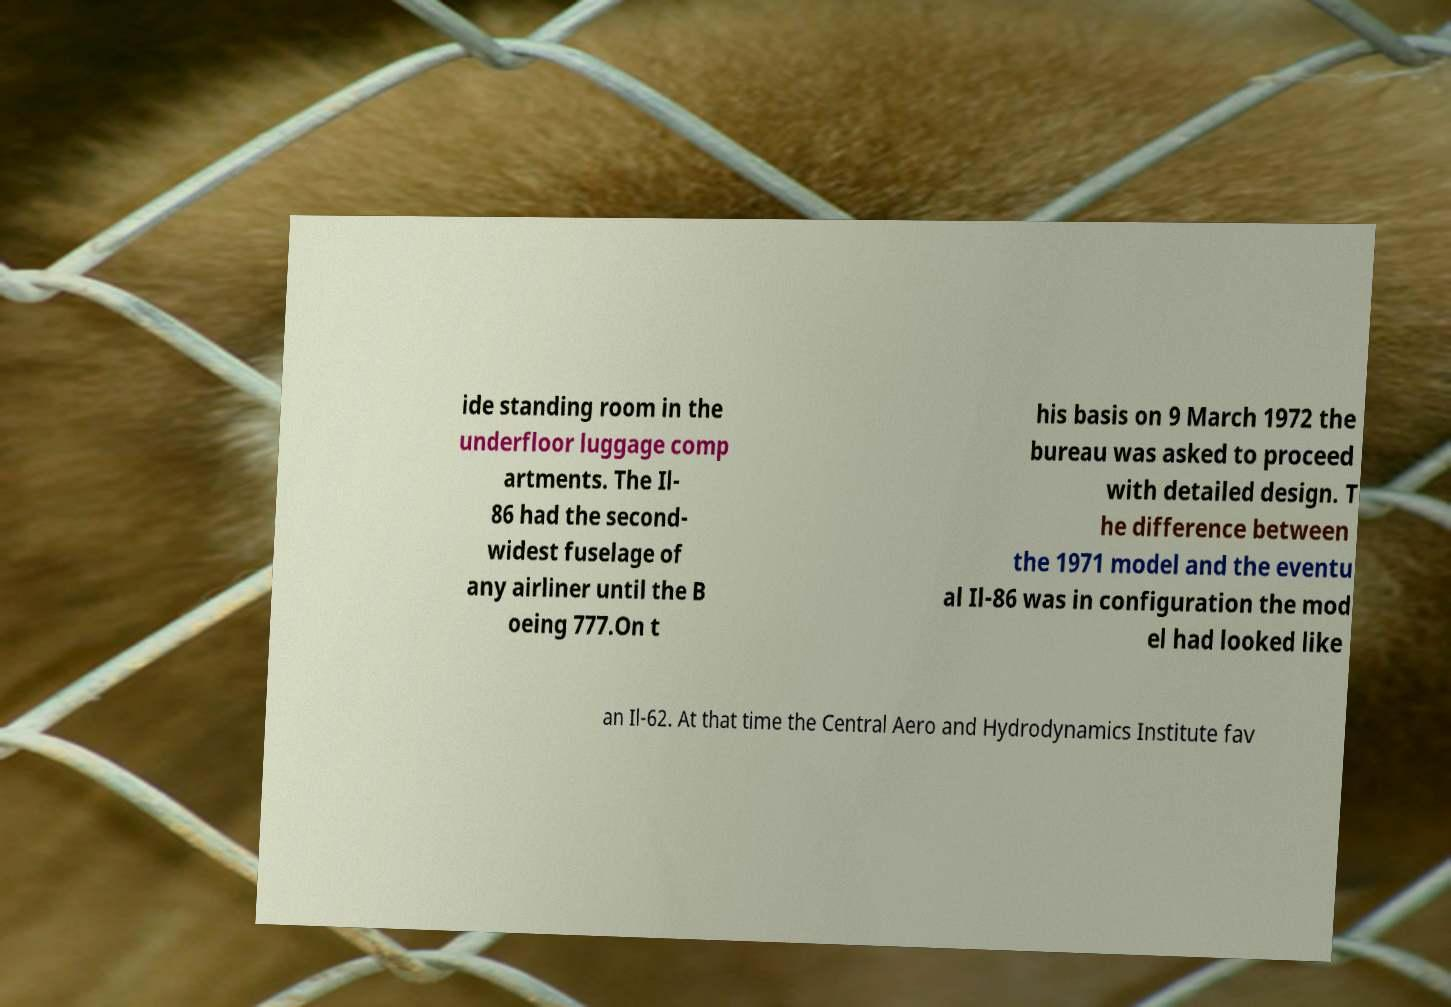Could you extract and type out the text from this image? ide standing room in the underfloor luggage comp artments. The Il- 86 had the second- widest fuselage of any airliner until the B oeing 777.On t his basis on 9 March 1972 the bureau was asked to proceed with detailed design. T he difference between the 1971 model and the eventu al Il-86 was in configuration the mod el had looked like an Il-62. At that time the Central Aero and Hydrodynamics Institute fav 